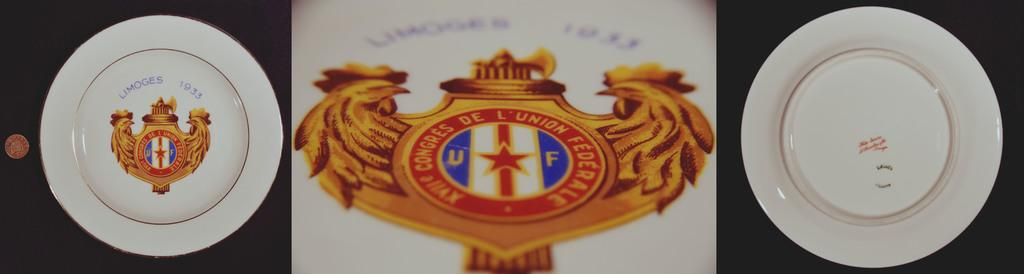What is the main feature of the image? There is a logo in the image. What else can be seen on the plate with the logo? There is text on a plate in the image. Are there any other plates visible in the image? Yes, there is another plate on the right side of the image. How many fields are visible in the image? There are no fields visible in the image. What force is being applied to the plate with the logo? There is no force being applied to the plate with the logo in the image. 